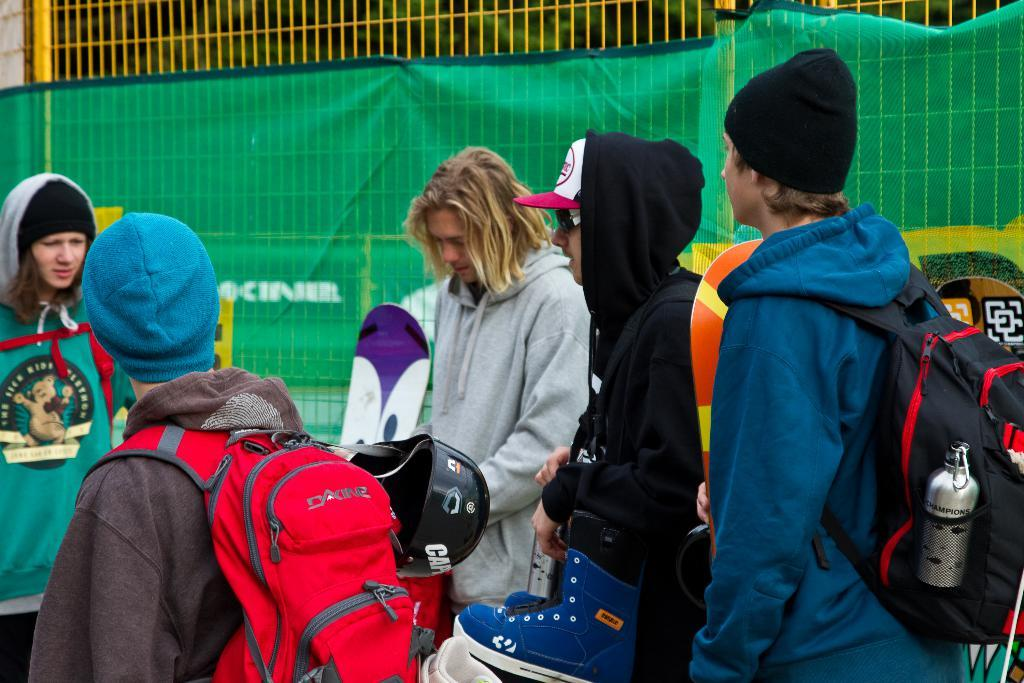Where was the image taken? The image was clicked outside. How many people are present in the image? There are many people in the image. What are some of the people carrying in the image? Some people are wearing backpacks. What can be seen in the background of the image? There is a net visible in the image. How many people are wearing caps in the image? Four people are wearing caps. What is the shape of the milk carton in the image? There is no milk carton present in the image. How does the square increase in size in the image? There is no square present in the image, so it cannot increase in size. 